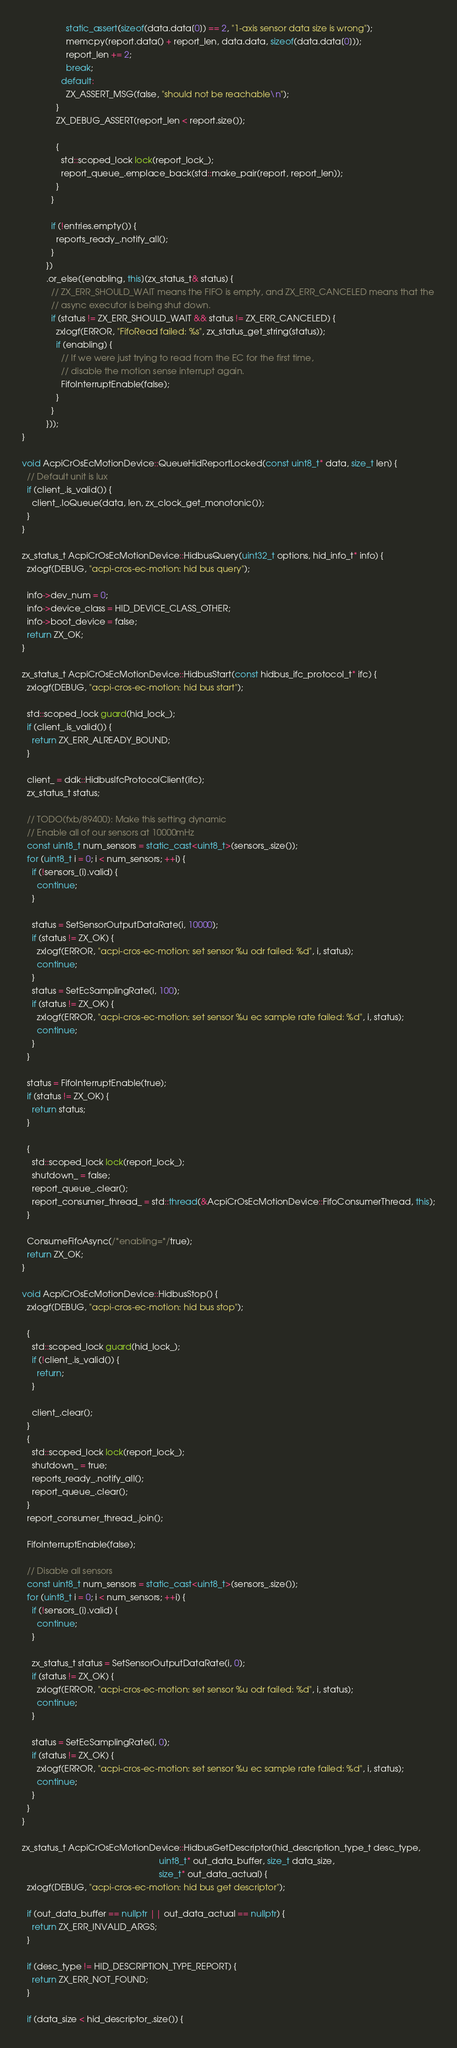Convert code to text. <code><loc_0><loc_0><loc_500><loc_500><_C++_>                  static_assert(sizeof(data.data[0]) == 2, "1-axis sensor data size is wrong");
                  memcpy(report.data() + report_len, data.data, sizeof(data.data[0]));
                  report_len += 2;
                  break;
                default:
                  ZX_ASSERT_MSG(false, "should not be reachable\n");
              }
              ZX_DEBUG_ASSERT(report_len < report.size());

              {
                std::scoped_lock lock(report_lock_);
                report_queue_.emplace_back(std::make_pair(report, report_len));
              }
            }

            if (!entries.empty()) {
              reports_ready_.notify_all();
            }
          })
          .or_else([enabling, this](zx_status_t& status) {
            // ZX_ERR_SHOULD_WAIT means the FIFO is empty, and ZX_ERR_CANCELED means that the
            // async executor is being shut down.
            if (status != ZX_ERR_SHOULD_WAIT && status != ZX_ERR_CANCELED) {
              zxlogf(ERROR, "FifoRead failed: %s", zx_status_get_string(status));
              if (enabling) {
                // If we were just trying to read from the EC for the first time,
                // disable the motion sense interrupt again.
                FifoInterruptEnable(false);
              }
            }
          }));
}

void AcpiCrOsEcMotionDevice::QueueHidReportLocked(const uint8_t* data, size_t len) {
  // Default unit is lux
  if (client_.is_valid()) {
    client_.IoQueue(data, len, zx_clock_get_monotonic());
  }
}

zx_status_t AcpiCrOsEcMotionDevice::HidbusQuery(uint32_t options, hid_info_t* info) {
  zxlogf(DEBUG, "acpi-cros-ec-motion: hid bus query");

  info->dev_num = 0;
  info->device_class = HID_DEVICE_CLASS_OTHER;
  info->boot_device = false;
  return ZX_OK;
}

zx_status_t AcpiCrOsEcMotionDevice::HidbusStart(const hidbus_ifc_protocol_t* ifc) {
  zxlogf(DEBUG, "acpi-cros-ec-motion: hid bus start");

  std::scoped_lock guard(hid_lock_);
  if (client_.is_valid()) {
    return ZX_ERR_ALREADY_BOUND;
  }

  client_ = ddk::HidbusIfcProtocolClient(ifc);
  zx_status_t status;

  // TODO(fxb/89400): Make this setting dynamic
  // Enable all of our sensors at 10000mHz
  const uint8_t num_sensors = static_cast<uint8_t>(sensors_.size());
  for (uint8_t i = 0; i < num_sensors; ++i) {
    if (!sensors_[i].valid) {
      continue;
    }

    status = SetSensorOutputDataRate(i, 10000);
    if (status != ZX_OK) {
      zxlogf(ERROR, "acpi-cros-ec-motion: set sensor %u odr failed: %d", i, status);
      continue;
    }
    status = SetEcSamplingRate(i, 100);
    if (status != ZX_OK) {
      zxlogf(ERROR, "acpi-cros-ec-motion: set sensor %u ec sample rate failed: %d", i, status);
      continue;
    }
  }

  status = FifoInterruptEnable(true);
  if (status != ZX_OK) {
    return status;
  }

  {
    std::scoped_lock lock(report_lock_);
    shutdown_ = false;
    report_queue_.clear();
    report_consumer_thread_ = std::thread(&AcpiCrOsEcMotionDevice::FifoConsumerThread, this);
  }

  ConsumeFifoAsync(/*enabling=*/true);
  return ZX_OK;
}

void AcpiCrOsEcMotionDevice::HidbusStop() {
  zxlogf(DEBUG, "acpi-cros-ec-motion: hid bus stop");

  {
    std::scoped_lock guard(hid_lock_);
    if (!client_.is_valid()) {
      return;
    }

    client_.clear();
  }
  {
    std::scoped_lock lock(report_lock_);
    shutdown_ = true;
    reports_ready_.notify_all();
    report_queue_.clear();
  }
  report_consumer_thread_.join();

  FifoInterruptEnable(false);

  // Disable all sensors
  const uint8_t num_sensors = static_cast<uint8_t>(sensors_.size());
  for (uint8_t i = 0; i < num_sensors; ++i) {
    if (!sensors_[i].valid) {
      continue;
    }

    zx_status_t status = SetSensorOutputDataRate(i, 0);
    if (status != ZX_OK) {
      zxlogf(ERROR, "acpi-cros-ec-motion: set sensor %u odr failed: %d", i, status);
      continue;
    }

    status = SetEcSamplingRate(i, 0);
    if (status != ZX_OK) {
      zxlogf(ERROR, "acpi-cros-ec-motion: set sensor %u ec sample rate failed: %d", i, status);
      continue;
    }
  }
}

zx_status_t AcpiCrOsEcMotionDevice::HidbusGetDescriptor(hid_description_type_t desc_type,
                                                        uint8_t* out_data_buffer, size_t data_size,
                                                        size_t* out_data_actual) {
  zxlogf(DEBUG, "acpi-cros-ec-motion: hid bus get descriptor");

  if (out_data_buffer == nullptr || out_data_actual == nullptr) {
    return ZX_ERR_INVALID_ARGS;
  }

  if (desc_type != HID_DESCRIPTION_TYPE_REPORT) {
    return ZX_ERR_NOT_FOUND;
  }

  if (data_size < hid_descriptor_.size()) {</code> 